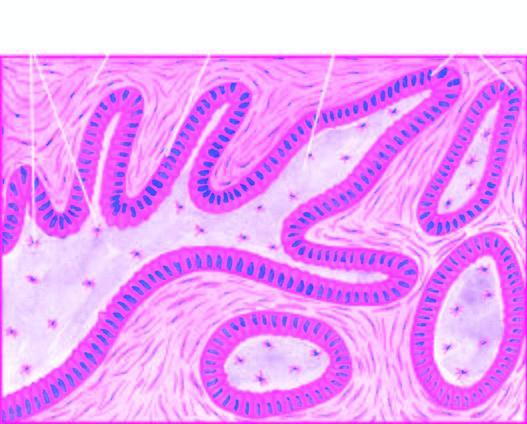do plexiform areas show irregular plexiform masses and network of strands of epithelial cells?
Answer the question using a single word or phrase. Yes 